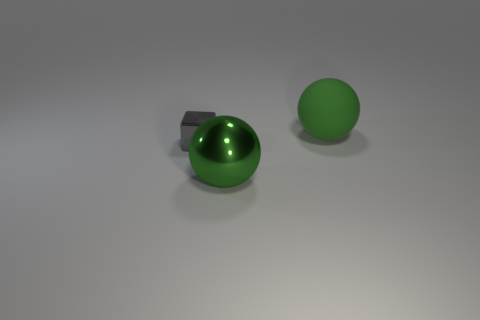Add 3 gray blocks. How many objects exist? 6 Subtract 1 blocks. How many blocks are left? 0 Add 1 metallic spheres. How many metallic spheres are left? 2 Add 2 shiny cubes. How many shiny cubes exist? 3 Subtract 0 gray cylinders. How many objects are left? 3 Subtract all spheres. How many objects are left? 1 Subtract all yellow blocks. Subtract all cyan cylinders. How many blocks are left? 1 Subtract all big shiny things. Subtract all big shiny objects. How many objects are left? 1 